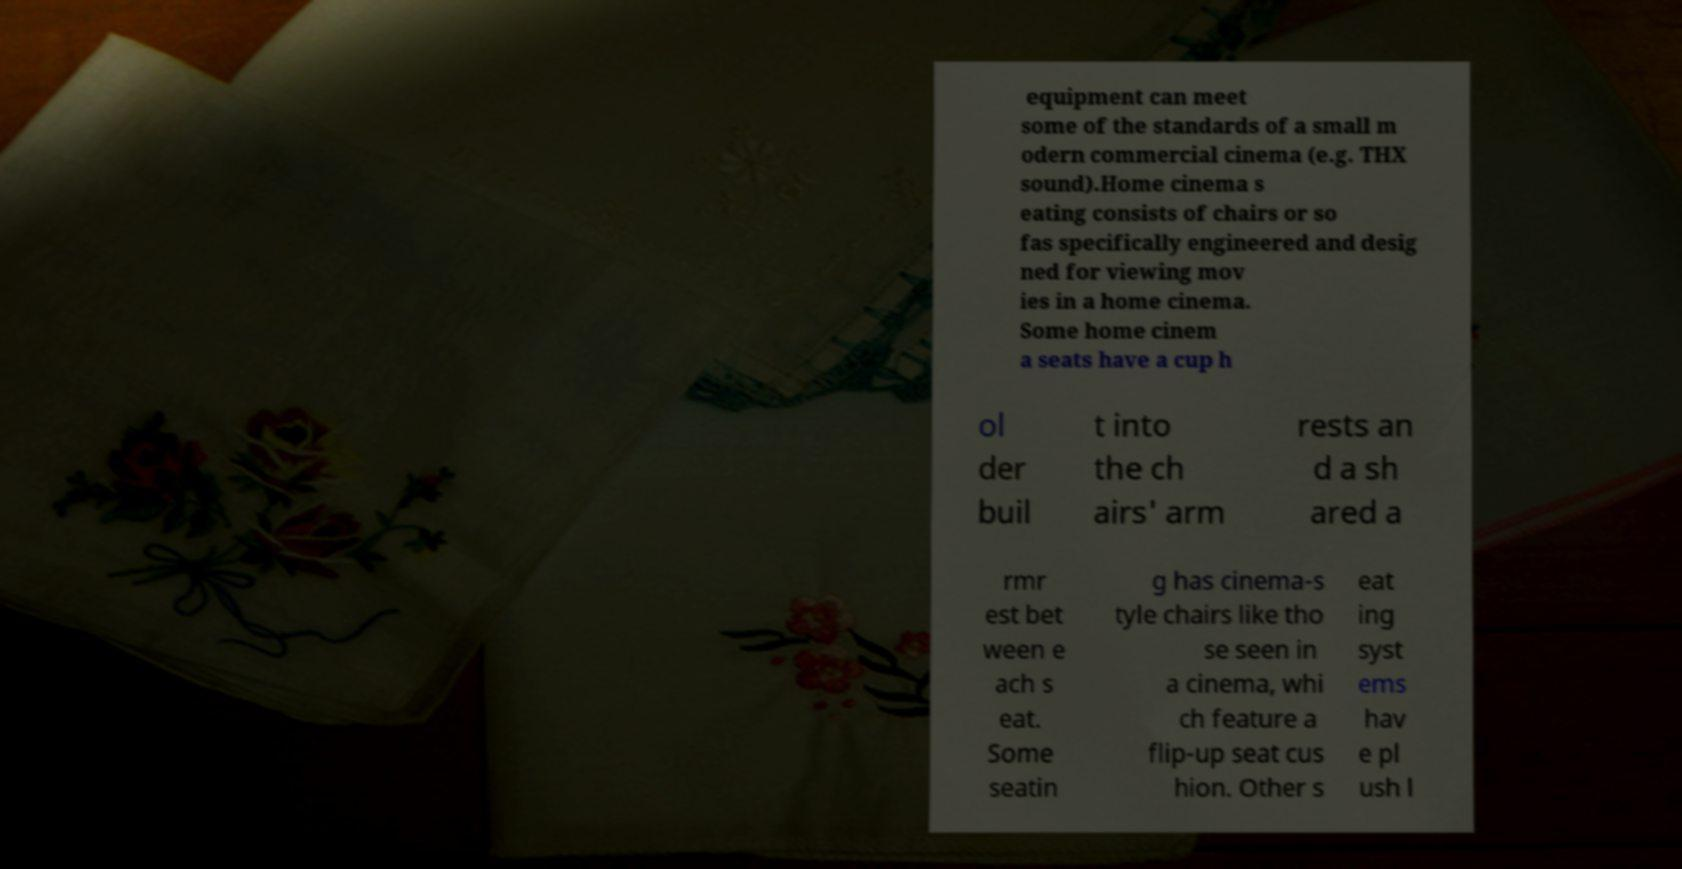Please read and relay the text visible in this image. What does it say? equipment can meet some of the standards of a small m odern commercial cinema (e.g. THX sound).Home cinema s eating consists of chairs or so fas specifically engineered and desig ned for viewing mov ies in a home cinema. Some home cinem a seats have a cup h ol der buil t into the ch airs' arm rests an d a sh ared a rmr est bet ween e ach s eat. Some seatin g has cinema-s tyle chairs like tho se seen in a cinema, whi ch feature a flip-up seat cus hion. Other s eat ing syst ems hav e pl ush l 